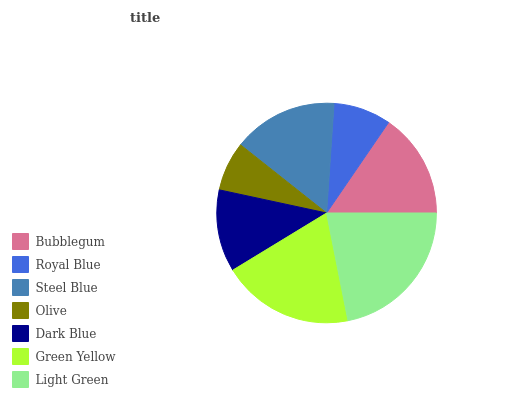Is Olive the minimum?
Answer yes or no. Yes. Is Light Green the maximum?
Answer yes or no. Yes. Is Royal Blue the minimum?
Answer yes or no. No. Is Royal Blue the maximum?
Answer yes or no. No. Is Bubblegum greater than Royal Blue?
Answer yes or no. Yes. Is Royal Blue less than Bubblegum?
Answer yes or no. Yes. Is Royal Blue greater than Bubblegum?
Answer yes or no. No. Is Bubblegum less than Royal Blue?
Answer yes or no. No. Is Steel Blue the high median?
Answer yes or no. Yes. Is Steel Blue the low median?
Answer yes or no. Yes. Is Light Green the high median?
Answer yes or no. No. Is Dark Blue the low median?
Answer yes or no. No. 